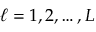<formula> <loc_0><loc_0><loc_500><loc_500>\ell = 1 , 2 , \dots , L</formula> 